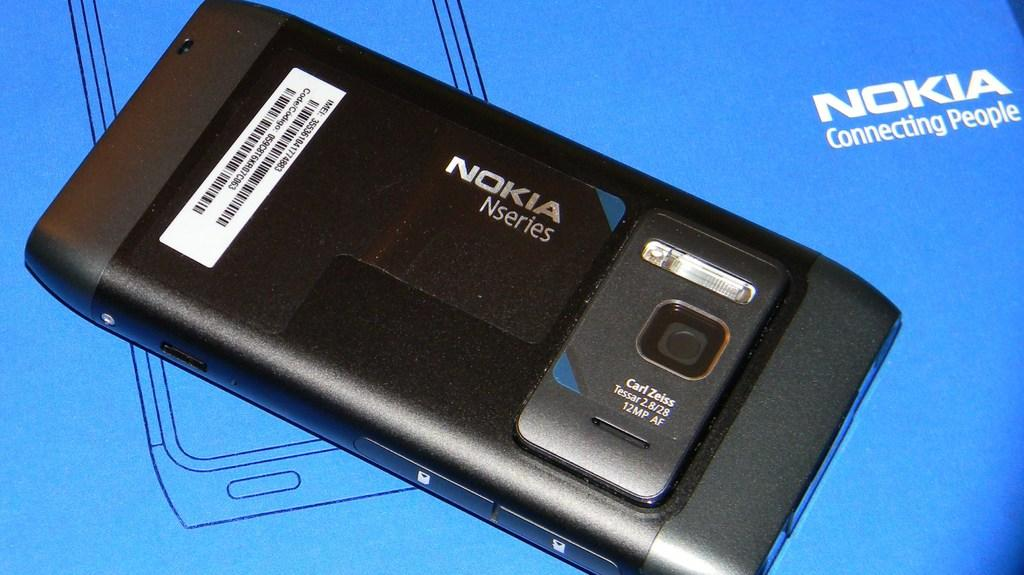<image>
Write a terse but informative summary of the picture. A Nokia phone sits with the battery exposed. 